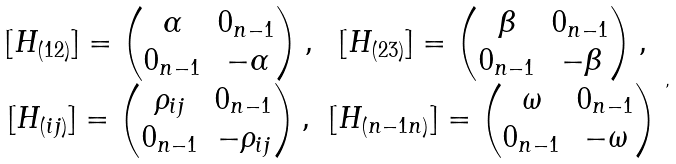Convert formula to latex. <formula><loc_0><loc_0><loc_500><loc_500>\begin{array} { c c } [ H _ { ( 1 2 ) } ] = \begin{pmatrix} \alpha & 0 _ { n - 1 } \\ 0 _ { n - 1 } & - \alpha \end{pmatrix} , & [ H _ { ( 2 3 ) } ] = \begin{pmatrix} \beta & 0 _ { n - 1 } \\ 0 _ { n - 1 } & - \beta \end{pmatrix} , \\ { [ H _ { ( i j ) } ] } = \begin{pmatrix} \rho _ { i j } & 0 _ { n - 1 } \\ 0 _ { n - 1 } & - \rho _ { i j } \end{pmatrix} , & [ H _ { ( n - 1 n ) } ] = \begin{pmatrix} \omega & 0 _ { n - 1 } \\ 0 _ { n - 1 } & - \omega \end{pmatrix} \end{array} ,</formula> 